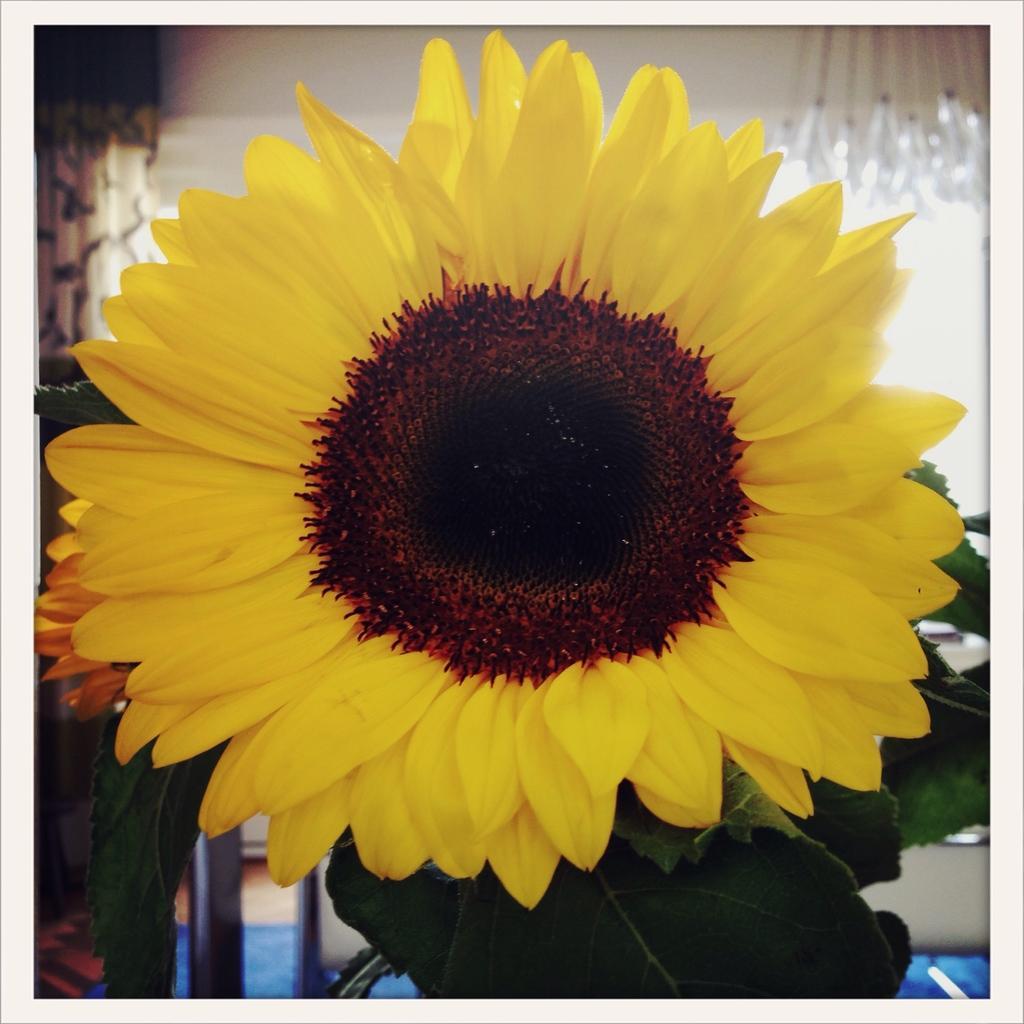How would you summarize this image in a sentence or two? In this image there is a sunflower, there are leaves truncated towards the bottom of the image, there is a curtain truncated towards the left of the image, there is an object truncated towards the top of the image, at the background of the image there is the wall. 